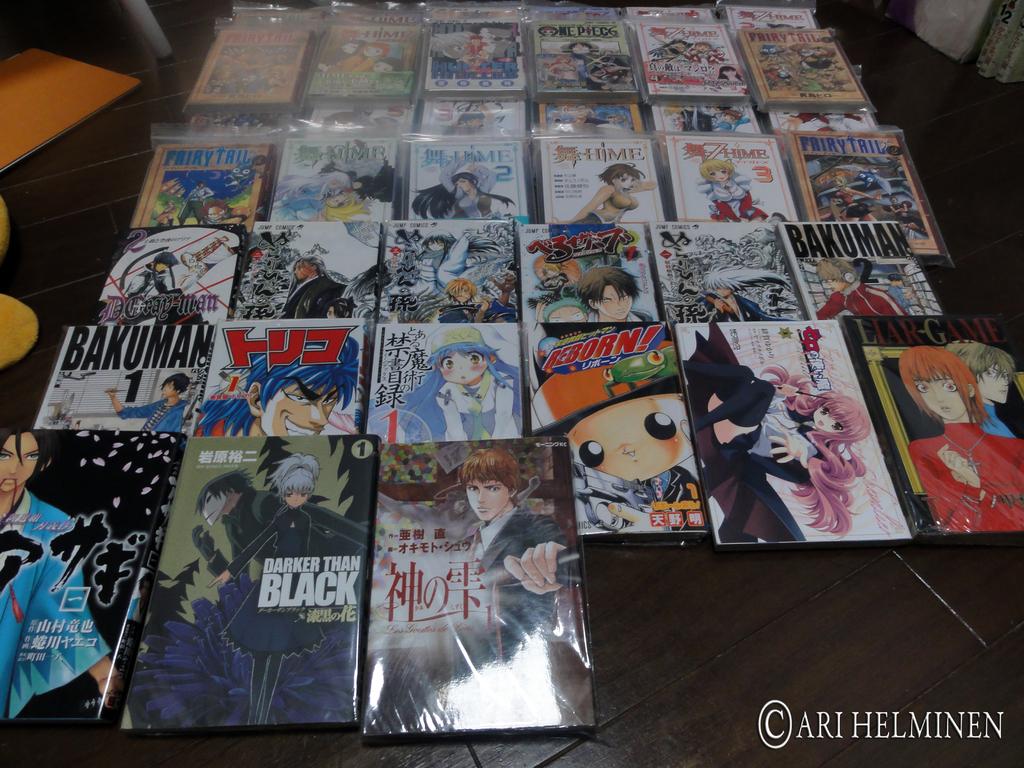What is a title of one of the comics?
Your answer should be very brief. Darker than black. Is one of the comics shown called "darker than black"?
Offer a very short reply. Yes. 